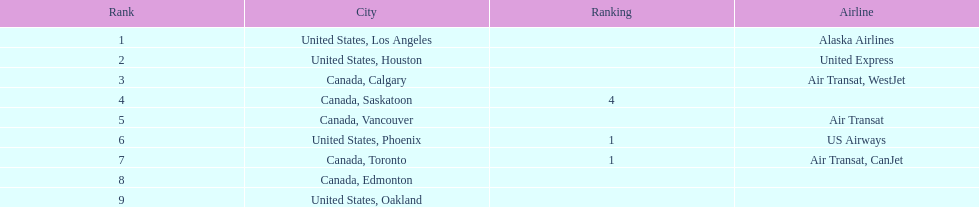What is the average number of passengers in the united states? 5537.5. Would you mind parsing the complete table? {'header': ['Rank', 'City', 'Ranking', 'Airline'], 'rows': [['1', 'United States, Los Angeles', '', 'Alaska Airlines'], ['2', 'United States, Houston', '', 'United Express'], ['3', 'Canada, Calgary', '', 'Air Transat, WestJet'], ['4', 'Canada, Saskatoon', '4', ''], ['5', 'Canada, Vancouver', '', 'Air Transat'], ['6', 'United States, Phoenix', '1', 'US Airways'], ['7', 'Canada, Toronto', '1', 'Air Transat, CanJet'], ['8', 'Canada, Edmonton', '', ''], ['9', 'United States, Oakland', '', '']]} 